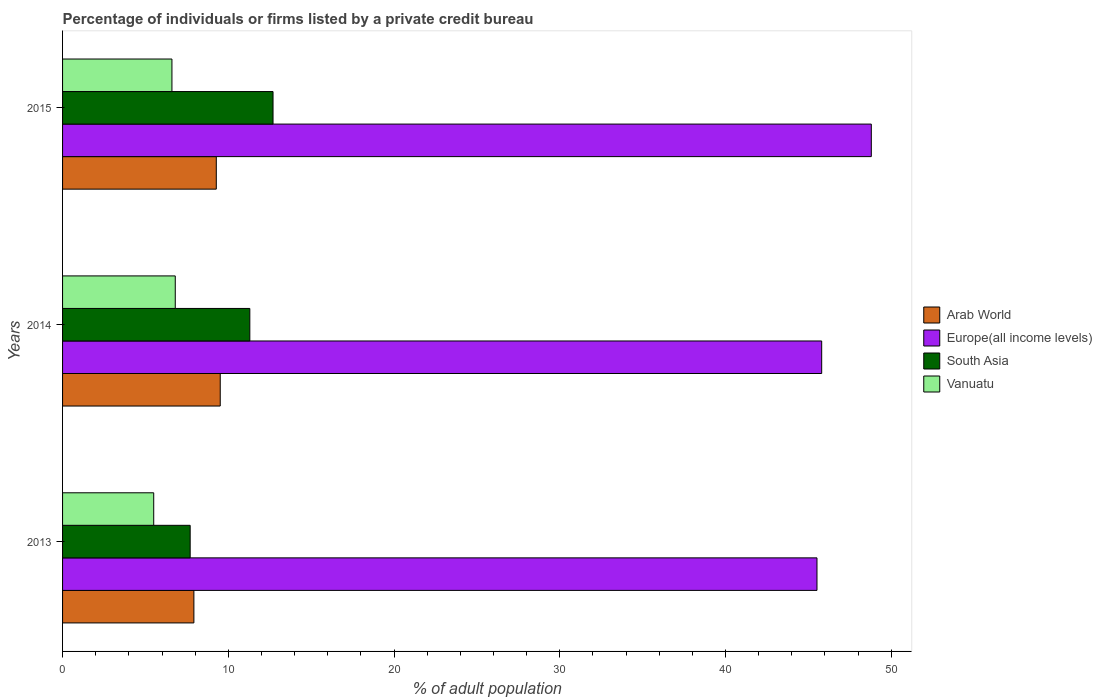What is the label of the 2nd group of bars from the top?
Provide a succinct answer. 2014. In how many cases, is the number of bars for a given year not equal to the number of legend labels?
Offer a terse response. 0. What is the percentage of population listed by a private credit bureau in Vanuatu in 2015?
Offer a terse response. 6.6. Across all years, what is the minimum percentage of population listed by a private credit bureau in Europe(all income levels)?
Offer a terse response. 45.52. In which year was the percentage of population listed by a private credit bureau in Europe(all income levels) maximum?
Ensure brevity in your answer.  2015. In which year was the percentage of population listed by a private credit bureau in Vanuatu minimum?
Your answer should be very brief. 2013. What is the total percentage of population listed by a private credit bureau in Europe(all income levels) in the graph?
Make the answer very short. 140.13. What is the difference between the percentage of population listed by a private credit bureau in Arab World in 2014 and that in 2015?
Your answer should be compact. 0.24. What is the difference between the percentage of population listed by a private credit bureau in Arab World in 2014 and the percentage of population listed by a private credit bureau in South Asia in 2013?
Your answer should be very brief. 1.81. What is the average percentage of population listed by a private credit bureau in Arab World per year?
Provide a succinct answer. 8.9. In the year 2015, what is the difference between the percentage of population listed by a private credit bureau in Europe(all income levels) and percentage of population listed by a private credit bureau in Vanuatu?
Ensure brevity in your answer.  42.2. What is the ratio of the percentage of population listed by a private credit bureau in Europe(all income levels) in 2013 to that in 2015?
Your response must be concise. 0.93. Is the percentage of population listed by a private credit bureau in Vanuatu in 2013 less than that in 2015?
Make the answer very short. Yes. Is the difference between the percentage of population listed by a private credit bureau in Europe(all income levels) in 2013 and 2015 greater than the difference between the percentage of population listed by a private credit bureau in Vanuatu in 2013 and 2015?
Your answer should be compact. No. What is the difference between the highest and the second highest percentage of population listed by a private credit bureau in South Asia?
Provide a succinct answer. 1.4. What is the difference between the highest and the lowest percentage of population listed by a private credit bureau in Vanuatu?
Offer a terse response. 1.3. Is the sum of the percentage of population listed by a private credit bureau in Europe(all income levels) in 2013 and 2014 greater than the maximum percentage of population listed by a private credit bureau in South Asia across all years?
Your answer should be compact. Yes. What does the 4th bar from the top in 2013 represents?
Your answer should be very brief. Arab World. What does the 3rd bar from the bottom in 2013 represents?
Your answer should be very brief. South Asia. Are all the bars in the graph horizontal?
Make the answer very short. Yes. How many years are there in the graph?
Provide a short and direct response. 3. Are the values on the major ticks of X-axis written in scientific E-notation?
Provide a succinct answer. No. Does the graph contain grids?
Your answer should be very brief. No. Where does the legend appear in the graph?
Your response must be concise. Center right. What is the title of the graph?
Provide a short and direct response. Percentage of individuals or firms listed by a private credit bureau. Does "Antigua and Barbuda" appear as one of the legend labels in the graph?
Keep it short and to the point. No. What is the label or title of the X-axis?
Offer a very short reply. % of adult population. What is the % of adult population in Arab World in 2013?
Your answer should be compact. 7.92. What is the % of adult population in Europe(all income levels) in 2013?
Provide a succinct answer. 45.52. What is the % of adult population in Arab World in 2014?
Ensure brevity in your answer.  9.51. What is the % of adult population of Europe(all income levels) in 2014?
Provide a succinct answer. 45.81. What is the % of adult population of Vanuatu in 2014?
Keep it short and to the point. 6.8. What is the % of adult population of Arab World in 2015?
Ensure brevity in your answer.  9.28. What is the % of adult population of Europe(all income levels) in 2015?
Keep it short and to the point. 48.8. What is the % of adult population in South Asia in 2015?
Provide a succinct answer. 12.7. Across all years, what is the maximum % of adult population of Arab World?
Offer a very short reply. 9.51. Across all years, what is the maximum % of adult population of Europe(all income levels)?
Provide a short and direct response. 48.8. Across all years, what is the maximum % of adult population of South Asia?
Your answer should be very brief. 12.7. Across all years, what is the maximum % of adult population of Vanuatu?
Offer a terse response. 6.8. Across all years, what is the minimum % of adult population in Arab World?
Make the answer very short. 7.92. Across all years, what is the minimum % of adult population in Europe(all income levels)?
Make the answer very short. 45.52. Across all years, what is the minimum % of adult population of Vanuatu?
Provide a succinct answer. 5.5. What is the total % of adult population in Arab World in the graph?
Your response must be concise. 26.71. What is the total % of adult population in Europe(all income levels) in the graph?
Keep it short and to the point. 140.13. What is the total % of adult population in South Asia in the graph?
Make the answer very short. 31.7. What is the total % of adult population in Vanuatu in the graph?
Keep it short and to the point. 18.9. What is the difference between the % of adult population of Arab World in 2013 and that in 2014?
Your answer should be very brief. -1.59. What is the difference between the % of adult population of Europe(all income levels) in 2013 and that in 2014?
Give a very brief answer. -0.28. What is the difference between the % of adult population in South Asia in 2013 and that in 2014?
Provide a succinct answer. -3.6. What is the difference between the % of adult population in Vanuatu in 2013 and that in 2014?
Give a very brief answer. -1.3. What is the difference between the % of adult population in Arab World in 2013 and that in 2015?
Provide a short and direct response. -1.35. What is the difference between the % of adult population in Europe(all income levels) in 2013 and that in 2015?
Offer a very short reply. -3.28. What is the difference between the % of adult population in South Asia in 2013 and that in 2015?
Your answer should be compact. -5. What is the difference between the % of adult population of Vanuatu in 2013 and that in 2015?
Offer a very short reply. -1.1. What is the difference between the % of adult population of Arab World in 2014 and that in 2015?
Provide a short and direct response. 0.24. What is the difference between the % of adult population in Europe(all income levels) in 2014 and that in 2015?
Offer a very short reply. -2.99. What is the difference between the % of adult population of South Asia in 2014 and that in 2015?
Your response must be concise. -1.4. What is the difference between the % of adult population in Arab World in 2013 and the % of adult population in Europe(all income levels) in 2014?
Offer a very short reply. -37.88. What is the difference between the % of adult population of Arab World in 2013 and the % of adult population of South Asia in 2014?
Offer a very short reply. -3.38. What is the difference between the % of adult population in Arab World in 2013 and the % of adult population in Vanuatu in 2014?
Your response must be concise. 1.12. What is the difference between the % of adult population in Europe(all income levels) in 2013 and the % of adult population in South Asia in 2014?
Offer a terse response. 34.22. What is the difference between the % of adult population of Europe(all income levels) in 2013 and the % of adult population of Vanuatu in 2014?
Provide a short and direct response. 38.72. What is the difference between the % of adult population in South Asia in 2013 and the % of adult population in Vanuatu in 2014?
Offer a very short reply. 0.9. What is the difference between the % of adult population of Arab World in 2013 and the % of adult population of Europe(all income levels) in 2015?
Your response must be concise. -40.88. What is the difference between the % of adult population of Arab World in 2013 and the % of adult population of South Asia in 2015?
Your response must be concise. -4.78. What is the difference between the % of adult population of Arab World in 2013 and the % of adult population of Vanuatu in 2015?
Offer a terse response. 1.32. What is the difference between the % of adult population in Europe(all income levels) in 2013 and the % of adult population in South Asia in 2015?
Offer a very short reply. 32.82. What is the difference between the % of adult population in Europe(all income levels) in 2013 and the % of adult population in Vanuatu in 2015?
Your response must be concise. 38.92. What is the difference between the % of adult population of South Asia in 2013 and the % of adult population of Vanuatu in 2015?
Ensure brevity in your answer.  1.1. What is the difference between the % of adult population in Arab World in 2014 and the % of adult population in Europe(all income levels) in 2015?
Make the answer very short. -39.29. What is the difference between the % of adult population of Arab World in 2014 and the % of adult population of South Asia in 2015?
Ensure brevity in your answer.  -3.19. What is the difference between the % of adult population of Arab World in 2014 and the % of adult population of Vanuatu in 2015?
Ensure brevity in your answer.  2.91. What is the difference between the % of adult population of Europe(all income levels) in 2014 and the % of adult population of South Asia in 2015?
Offer a very short reply. 33.11. What is the difference between the % of adult population of Europe(all income levels) in 2014 and the % of adult population of Vanuatu in 2015?
Your answer should be compact. 39.21. What is the difference between the % of adult population of South Asia in 2014 and the % of adult population of Vanuatu in 2015?
Offer a terse response. 4.7. What is the average % of adult population of Arab World per year?
Provide a short and direct response. 8.9. What is the average % of adult population in Europe(all income levels) per year?
Your answer should be compact. 46.71. What is the average % of adult population in South Asia per year?
Your response must be concise. 10.57. What is the average % of adult population of Vanuatu per year?
Provide a succinct answer. 6.3. In the year 2013, what is the difference between the % of adult population of Arab World and % of adult population of Europe(all income levels)?
Offer a terse response. -37.6. In the year 2013, what is the difference between the % of adult population of Arab World and % of adult population of South Asia?
Your answer should be very brief. 0.22. In the year 2013, what is the difference between the % of adult population in Arab World and % of adult population in Vanuatu?
Offer a terse response. 2.42. In the year 2013, what is the difference between the % of adult population in Europe(all income levels) and % of adult population in South Asia?
Your response must be concise. 37.82. In the year 2013, what is the difference between the % of adult population in Europe(all income levels) and % of adult population in Vanuatu?
Make the answer very short. 40.02. In the year 2013, what is the difference between the % of adult population in South Asia and % of adult population in Vanuatu?
Provide a succinct answer. 2.2. In the year 2014, what is the difference between the % of adult population of Arab World and % of adult population of Europe(all income levels)?
Offer a terse response. -36.29. In the year 2014, what is the difference between the % of adult population of Arab World and % of adult population of South Asia?
Your response must be concise. -1.79. In the year 2014, what is the difference between the % of adult population of Arab World and % of adult population of Vanuatu?
Provide a short and direct response. 2.71. In the year 2014, what is the difference between the % of adult population in Europe(all income levels) and % of adult population in South Asia?
Offer a terse response. 34.51. In the year 2014, what is the difference between the % of adult population of Europe(all income levels) and % of adult population of Vanuatu?
Your response must be concise. 39.01. In the year 2014, what is the difference between the % of adult population in South Asia and % of adult population in Vanuatu?
Your answer should be compact. 4.5. In the year 2015, what is the difference between the % of adult population of Arab World and % of adult population of Europe(all income levels)?
Make the answer very short. -39.52. In the year 2015, what is the difference between the % of adult population of Arab World and % of adult population of South Asia?
Provide a short and direct response. -3.42. In the year 2015, what is the difference between the % of adult population in Arab World and % of adult population in Vanuatu?
Your response must be concise. 2.68. In the year 2015, what is the difference between the % of adult population in Europe(all income levels) and % of adult population in South Asia?
Make the answer very short. 36.1. In the year 2015, what is the difference between the % of adult population in Europe(all income levels) and % of adult population in Vanuatu?
Ensure brevity in your answer.  42.2. What is the ratio of the % of adult population of Arab World in 2013 to that in 2014?
Keep it short and to the point. 0.83. What is the ratio of the % of adult population in Europe(all income levels) in 2013 to that in 2014?
Offer a terse response. 0.99. What is the ratio of the % of adult population of South Asia in 2013 to that in 2014?
Offer a very short reply. 0.68. What is the ratio of the % of adult population in Vanuatu in 2013 to that in 2014?
Keep it short and to the point. 0.81. What is the ratio of the % of adult population in Arab World in 2013 to that in 2015?
Make the answer very short. 0.85. What is the ratio of the % of adult population of Europe(all income levels) in 2013 to that in 2015?
Provide a succinct answer. 0.93. What is the ratio of the % of adult population of South Asia in 2013 to that in 2015?
Provide a short and direct response. 0.61. What is the ratio of the % of adult population in Vanuatu in 2013 to that in 2015?
Keep it short and to the point. 0.83. What is the ratio of the % of adult population in Arab World in 2014 to that in 2015?
Your answer should be compact. 1.03. What is the ratio of the % of adult population of Europe(all income levels) in 2014 to that in 2015?
Ensure brevity in your answer.  0.94. What is the ratio of the % of adult population of South Asia in 2014 to that in 2015?
Give a very brief answer. 0.89. What is the ratio of the % of adult population of Vanuatu in 2014 to that in 2015?
Your response must be concise. 1.03. What is the difference between the highest and the second highest % of adult population in Arab World?
Offer a very short reply. 0.24. What is the difference between the highest and the second highest % of adult population in Europe(all income levels)?
Offer a terse response. 2.99. What is the difference between the highest and the second highest % of adult population in South Asia?
Your answer should be compact. 1.4. What is the difference between the highest and the second highest % of adult population of Vanuatu?
Make the answer very short. 0.2. What is the difference between the highest and the lowest % of adult population of Arab World?
Your answer should be very brief. 1.59. What is the difference between the highest and the lowest % of adult population in Europe(all income levels)?
Your response must be concise. 3.28. What is the difference between the highest and the lowest % of adult population in South Asia?
Offer a very short reply. 5. 